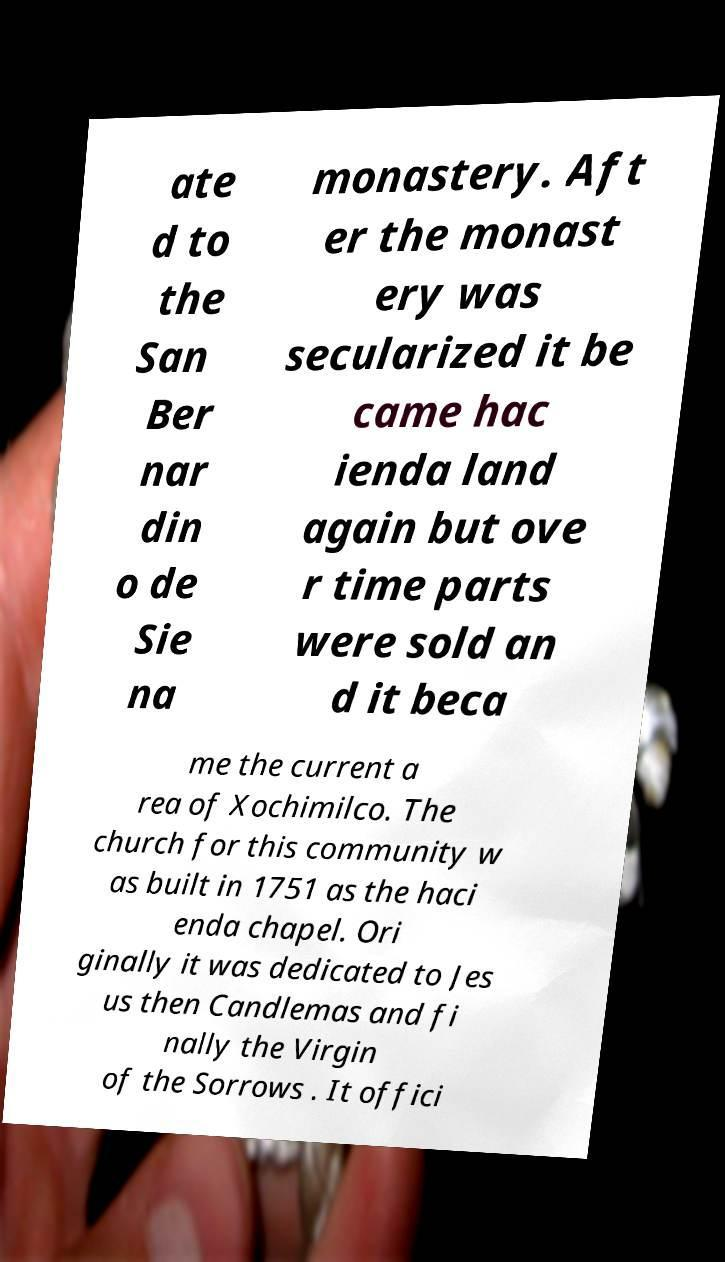What messages or text are displayed in this image? I need them in a readable, typed format. ate d to the San Ber nar din o de Sie na monastery. Aft er the monast ery was secularized it be came hac ienda land again but ove r time parts were sold an d it beca me the current a rea of Xochimilco. The church for this community w as built in 1751 as the haci enda chapel. Ori ginally it was dedicated to Jes us then Candlemas and fi nally the Virgin of the Sorrows . It offici 